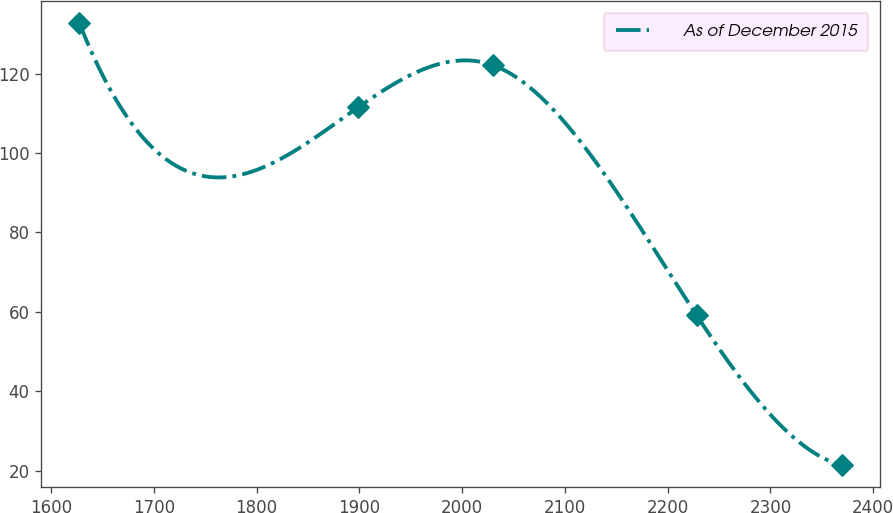Convert chart. <chart><loc_0><loc_0><loc_500><loc_500><line_chart><ecel><fcel>As of December 2015<nl><fcel>1627.51<fcel>132.74<nl><fcel>1898.89<fcel>111.52<nl><fcel>2029.89<fcel>122.13<nl><fcel>2228.1<fcel>59.18<nl><fcel>2369.26<fcel>21.41<nl></chart> 